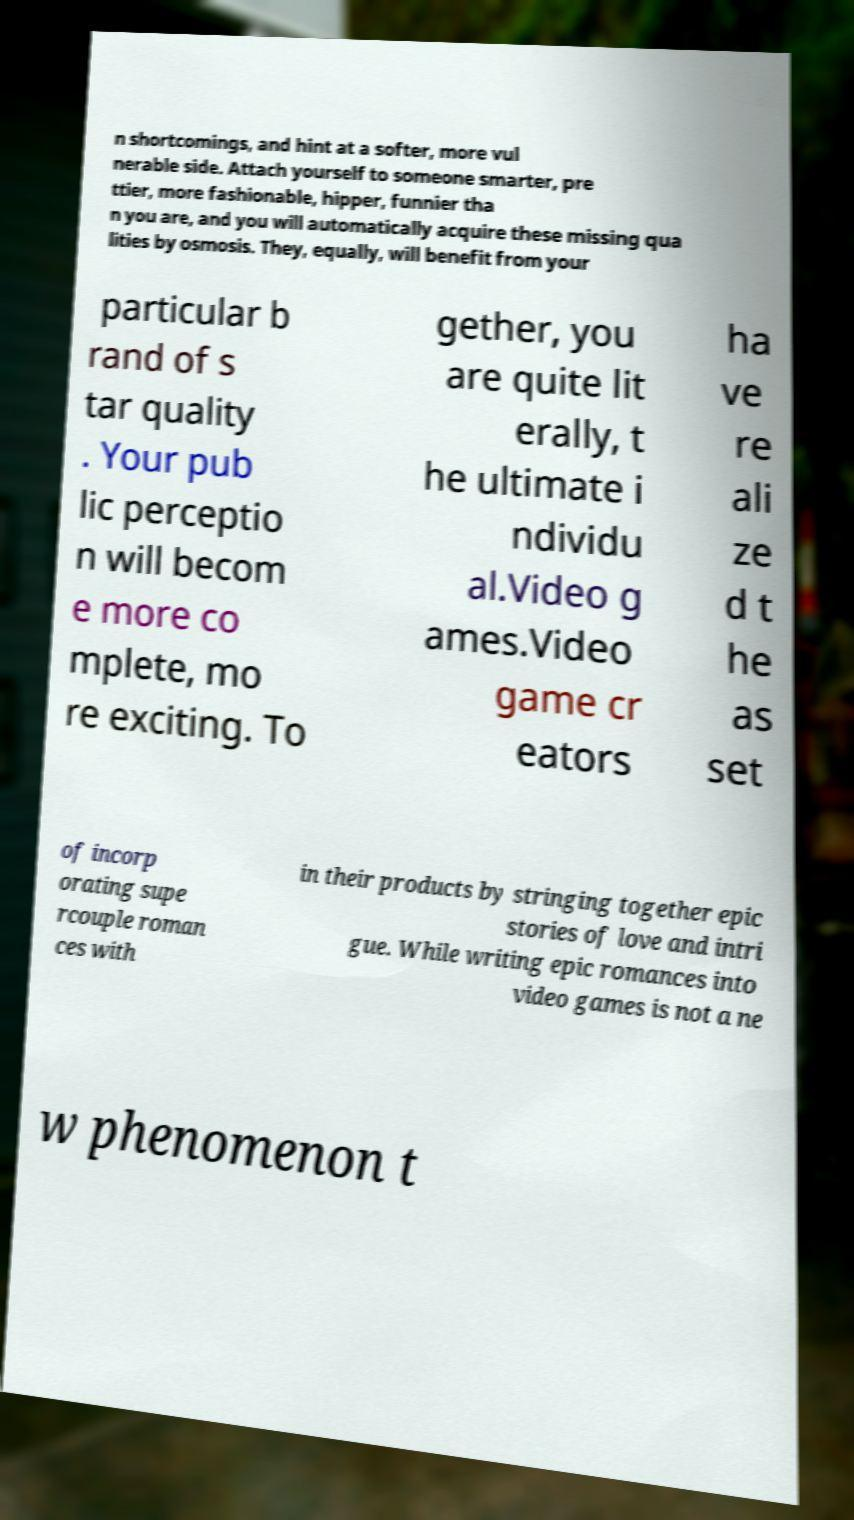I need the written content from this picture converted into text. Can you do that? n shortcomings, and hint at a softer, more vul nerable side. Attach yourself to someone smarter, pre ttier, more fashionable, hipper, funnier tha n you are, and you will automatically acquire these missing qua lities by osmosis. They, equally, will benefit from your particular b rand of s tar quality . Your pub lic perceptio n will becom e more co mplete, mo re exciting. To gether, you are quite lit erally, t he ultimate i ndividu al.Video g ames.Video game cr eators ha ve re ali ze d t he as set of incorp orating supe rcouple roman ces with in their products by stringing together epic stories of love and intri gue. While writing epic romances into video games is not a ne w phenomenon t 